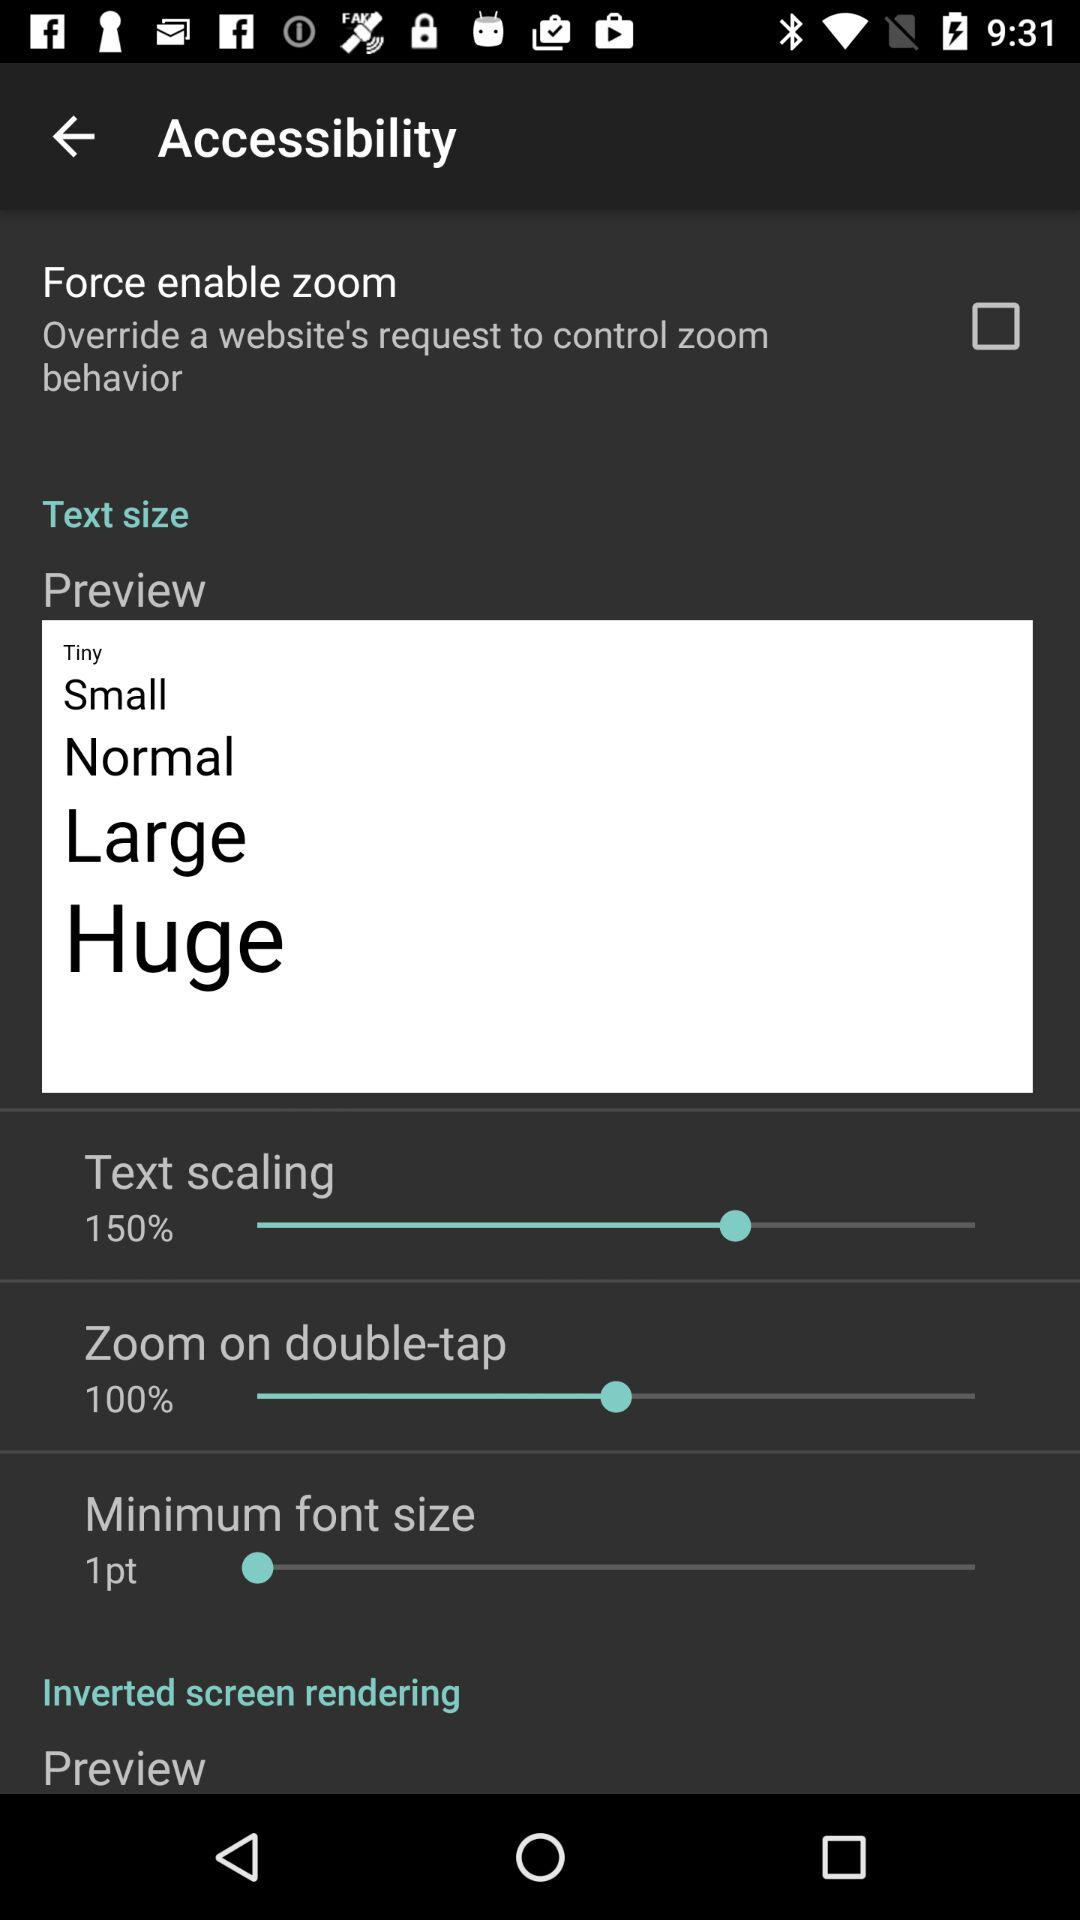How many text size options are there?
Answer the question using a single word or phrase. 5 